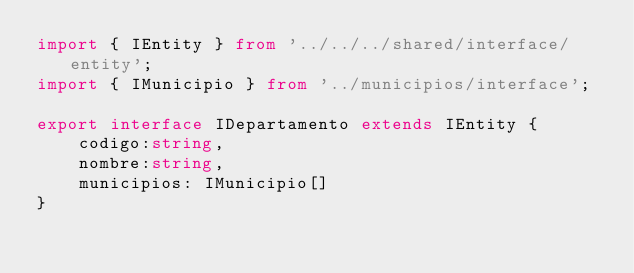Convert code to text. <code><loc_0><loc_0><loc_500><loc_500><_TypeScript_>import { IEntity } from '../../../shared/interface/entity';
import { IMunicipio } from '../municipios/interface';

export interface IDepartamento extends IEntity {
  	codigo:string, 
  	nombre:string,
  	municipios: IMunicipio[]
}</code> 